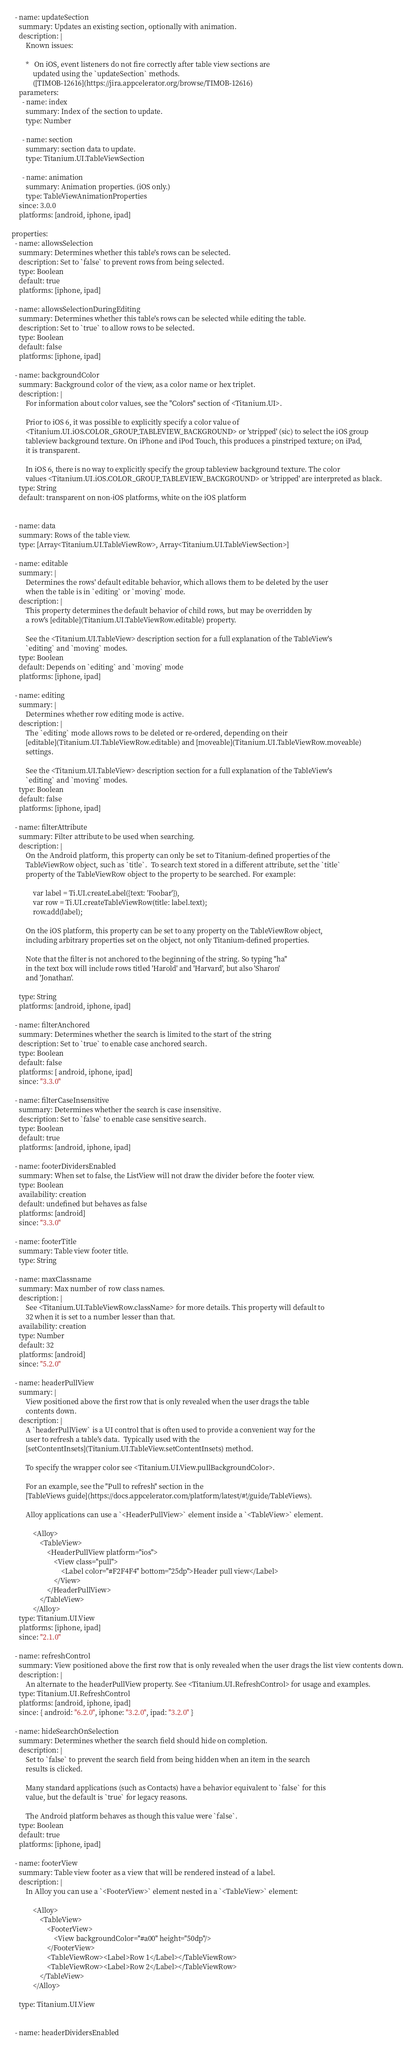<code> <loc_0><loc_0><loc_500><loc_500><_YAML_>
  - name: updateSection
    summary: Updates an existing section, optionally with animation.
    description: |
        Known issues:

        *   On iOS, event listeners do not fire correctly after table view sections are
            updated using the `updateSection` methods.
            ([TIMOB-12616](https://jira.appcelerator.org/browse/TIMOB-12616)
    parameters:
      - name: index
        summary: Index of the section to update.
        type: Number

      - name: section
        summary: section data to update.
        type: Titanium.UI.TableViewSection

      - name: animation
        summary: Animation properties. (iOS only.)
        type: TableViewAnimationProperties
    since: 3.0.0
    platforms: [android, iphone, ipad]

properties:
  - name: allowsSelection
    summary: Determines whether this table's rows can be selected.
    description: Set to `false` to prevent rows from being selected.
    type: Boolean
    default: true
    platforms: [iphone, ipad]

  - name: allowsSelectionDuringEditing
    summary: Determines whether this table's rows can be selected while editing the table.
    description: Set to `true` to allow rows to be selected.
    type: Boolean
    default: false
    platforms: [iphone, ipad]

  - name: backgroundColor
    summary: Background color of the view, as a color name or hex triplet.
    description: |
        For information about color values, see the "Colors" section of <Titanium.UI>.

        Prior to iOS 6, it was possible to explicitly specify a color value of
        <Titanium.UI.iOS.COLOR_GROUP_TABLEVIEW_BACKGROUND> or 'stripped' (sic) to select the iOS group
        tableview background texture. On iPhone and iPod Touch, this produces a pinstriped texture; on iPad,
        it is transparent.

        In iOS 6, there is no way to explicitly specify the group tableview background texture. The color
        values <Titanium.UI.iOS.COLOR_GROUP_TABLEVIEW_BACKGROUND> or 'stripped' are interpreted as black.
    type: String
    default: transparent on non-iOS platforms, white on the iOS platform


  - name: data
    summary: Rows of the table view.
    type: [Array<Titanium.UI.TableViewRow>, Array<Titanium.UI.TableViewSection>]

  - name: editable
    summary: |
        Determines the rows' default editable behavior, which allows them to be deleted by the user
        when the table is in `editing` or `moving` mode.
    description: |
        This property determines the default behavior of child rows, but may be overridden by
        a row's [editable](Titanium.UI.TableViewRow.editable) property.

        See the <Titanium.UI.TableView> description section for a full explanation of the TableView's
        `editing` and `moving` modes.
    type: Boolean
    default: Depends on `editing` and `moving` mode
    platforms: [iphone, ipad]

  - name: editing
    summary: |
        Determines whether row editing mode is active.
    description: |
        The `editing` mode allows rows to be deleted or re-ordered, depending on their
        [editable](Titanium.UI.TableViewRow.editable) and [moveable](Titanium.UI.TableViewRow.moveable)
        settings.

        See the <Titanium.UI.TableView> description section for a full explanation of the TableView's
        `editing` and `moving` modes.
    type: Boolean
    default: false
    platforms: [iphone, ipad]

  - name: filterAttribute
    summary: Filter attribute to be used when searching.
    description: |
        On the Android platform, this property can only be set to Titanium-defined properties of the
        TableViewRow object, such as `title`.  To search text stored in a different attribute, set the `title`
        property of the TableViewRow object to the property to be searched. For example:

            var label = Ti.UI.createLabel({text: 'Foobar'}),
            var row = Ti.UI.createTableViewRow(title: label.text);
            row.add(label);

        On the iOS platform, this property can be set to any property on the TableViewRow object,
        including arbitrary properties set on the object, not only Titanium-defined properties.

        Note that the filter is not anchored to the beginning of the string. So typing "ha"
        in the text box will include rows titled 'Harold' and 'Harvard', but also 'Sharon'
        and 'Jonathan'.

    type: String
    platforms: [android, iphone, ipad]

  - name: filterAnchored
    summary: Determines whether the search is limited to the start of the string
    description: Set to `true` to enable case anchored search.
    type: Boolean
    default: false
    platforms: [ android, iphone, ipad]
    since: "3.3.0"

  - name: filterCaseInsensitive
    summary: Determines whether the search is case insensitive.
    description: Set to `false` to enable case sensitive search.
    type: Boolean
    default: true
    platforms: [android, iphone, ipad]

  - name: footerDividersEnabled
    summary: When set to false, the ListView will not draw the divider before the footer view.
    type: Boolean
    availability: creation
    default: undefined but behaves as false
    platforms: [android]
    since: "3.3.0"

  - name: footerTitle
    summary: Table view footer title.
    type: String

  - name: maxClassname
    summary: Max number of row class names.
    description: |
        See <Titanium.UI.TableViewRow.className> for more details. This property will default to
        32 when it is set to a number lesser than that.
    availability: creation
    type: Number
    default: 32
    platforms: [android]
    since: "5.2.0"

  - name: headerPullView
    summary: |
        View positioned above the first row that is only revealed when the user drags the table
        contents down.
    description: |
        A `headerPullView` is a UI control that is often used to provide a convenient way for the
        user to refresh a table's data.  Typically used with the
        [setContentInsets](Titanium.UI.TableView.setContentInsets) method.

        To specify the wrapper color see <Titanium.UI.View.pullBackgroundColor>.

        For an example, see the "Pull to refresh" section in the
        [TableViews guide](https://docs.appcelerator.com/platform/latest/#!/guide/TableViews).

        Alloy applications can use a `<HeaderPullView>` element inside a `<TableView>` element.

            <Alloy>
                <TableView>
                    <HeaderPullView platform="ios">
                        <View class="pull">
                            <Label color="#F2F4F4" bottom="25dp">Header pull view</Label>
                        </View>
                    </HeaderPullView>
                </TableView>
            </Alloy>
    type: Titanium.UI.View
    platforms: [iphone, ipad]
    since: "2.1.0"

  - name: refreshControl
    summary: View positioned above the first row that is only revealed when the user drags the list view contents down.
    description: |
        An alternate to the headerPullView property. See <Titanium.UI.RefreshControl> for usage and examples.
    type: Titanium.UI.RefreshControl
    platforms: [android, iphone, ipad]
    since: { android: "6.2.0", iphone: "3.2.0", ipad: "3.2.0" }

  - name: hideSearchOnSelection
    summary: Determines whether the search field should hide on completion.
    description: |
        Set to `false` to prevent the search field from being hidden when an item in the search
        results is clicked.

        Many standard applications (such as Contacts) have a behavior equivalent to `false` for this
        value, but the default is `true` for legacy reasons.

        The Android platform behaves as though this value were `false`.
    type: Boolean
    default: true
    platforms: [iphone, ipad]

  - name: footerView
    summary: Table view footer as a view that will be rendered instead of a label.
    description: |
        In Alloy you can use a `<FooterView>` element nested in a `<TableView>` element:

            <Alloy>
                <TableView>
                    <FooterView>
                        <View backgroundColor="#a00" height="50dp"/>
                    </FooterView>
                    <TableViewRow><Label>Row 1</Label></TableViewRow>
                    <TableViewRow><Label>Row 2</Label></TableViewRow>
                </TableView>
            </Alloy>

    type: Titanium.UI.View


  - name: headerDividersEnabled</code> 